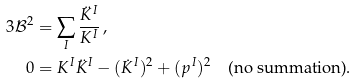Convert formula to latex. <formula><loc_0><loc_0><loc_500><loc_500>3 \mathcal { B } ^ { 2 } & = \sum _ { I } \frac { \ddot { K } ^ { I } } { K ^ { I } } \, , \\ 0 & = K ^ { I } \ddot { K } ^ { I } - ( \dot { K } ^ { I } ) ^ { 2 } + ( p ^ { I } ) ^ { 2 } \quad \text {(no summation)} .</formula> 